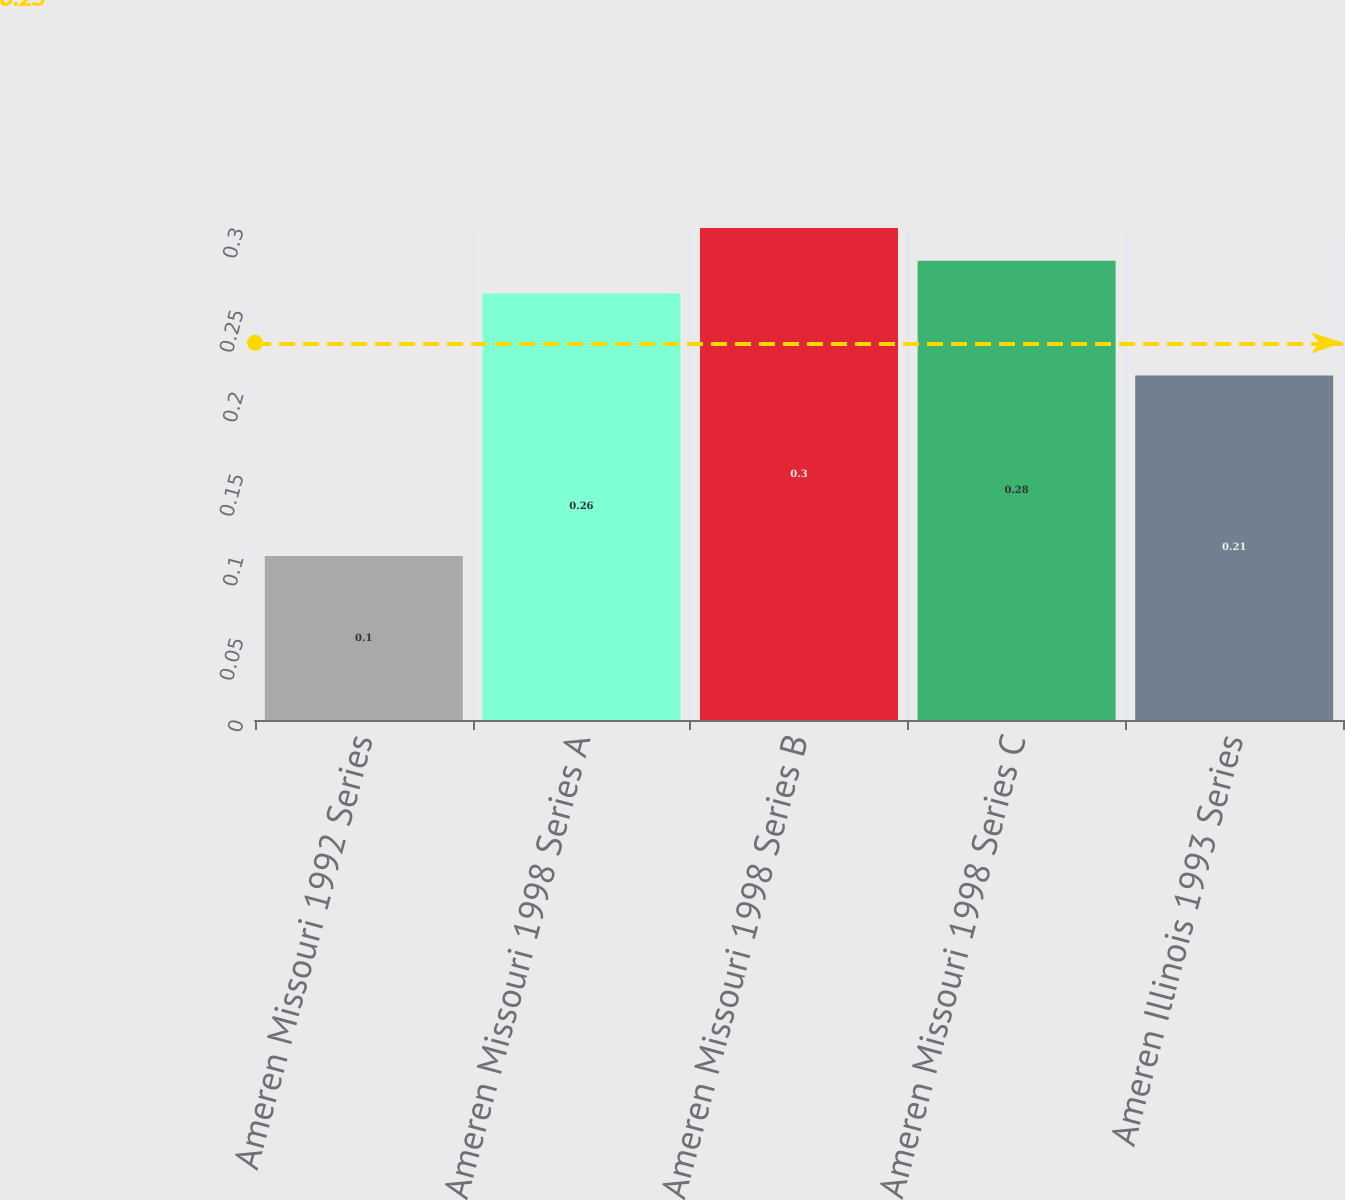Convert chart to OTSL. <chart><loc_0><loc_0><loc_500><loc_500><bar_chart><fcel>Ameren Missouri 1992 Series<fcel>Ameren Missouri 1998 Series A<fcel>Ameren Missouri 1998 Series B<fcel>Ameren Missouri 1998 Series C<fcel>Ameren Illinois 1993 Series<nl><fcel>0.1<fcel>0.26<fcel>0.3<fcel>0.28<fcel>0.21<nl></chart> 